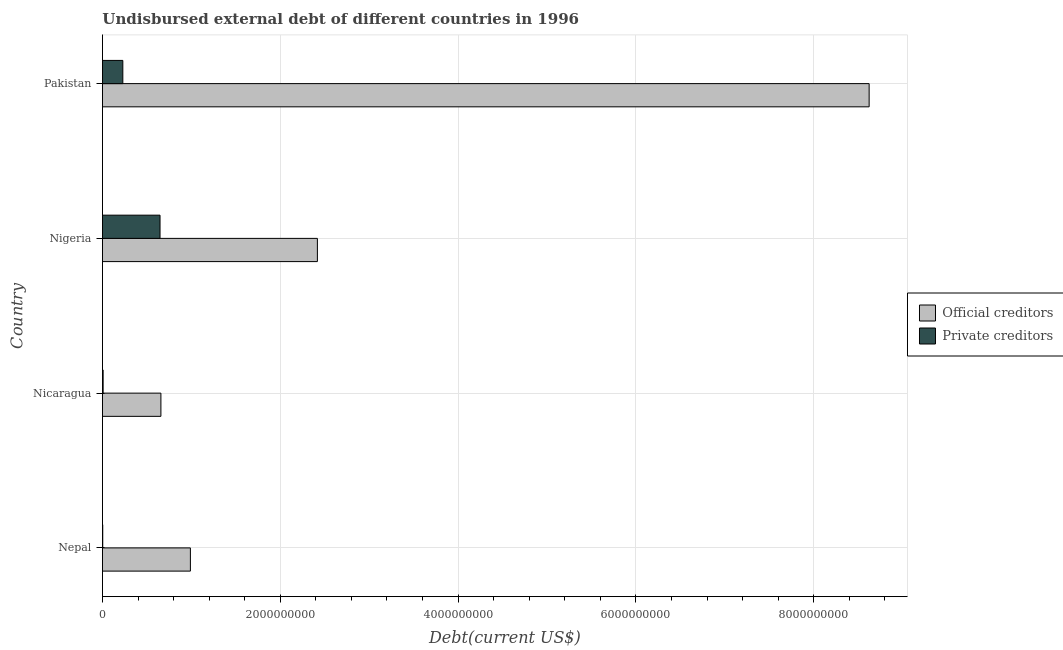Are the number of bars on each tick of the Y-axis equal?
Give a very brief answer. Yes. How many bars are there on the 4th tick from the bottom?
Your response must be concise. 2. What is the label of the 4th group of bars from the top?
Provide a short and direct response. Nepal. In how many cases, is the number of bars for a given country not equal to the number of legend labels?
Your answer should be very brief. 0. What is the undisbursed external debt of official creditors in Nepal?
Keep it short and to the point. 9.89e+08. Across all countries, what is the maximum undisbursed external debt of private creditors?
Offer a terse response. 6.48e+08. Across all countries, what is the minimum undisbursed external debt of official creditors?
Give a very brief answer. 6.57e+08. In which country was the undisbursed external debt of private creditors maximum?
Offer a very short reply. Nigeria. In which country was the undisbursed external debt of official creditors minimum?
Provide a succinct answer. Nicaragua. What is the total undisbursed external debt of private creditors in the graph?
Ensure brevity in your answer.  8.87e+08. What is the difference between the undisbursed external debt of official creditors in Nigeria and that in Pakistan?
Provide a short and direct response. -6.21e+09. What is the difference between the undisbursed external debt of private creditors in Pakistan and the undisbursed external debt of official creditors in Nepal?
Provide a short and direct response. -7.60e+08. What is the average undisbursed external debt of official creditors per country?
Give a very brief answer. 3.17e+09. What is the difference between the undisbursed external debt of private creditors and undisbursed external debt of official creditors in Nepal?
Give a very brief answer. -9.86e+08. What is the ratio of the undisbursed external debt of official creditors in Nicaragua to that in Pakistan?
Your answer should be very brief. 0.08. What is the difference between the highest and the second highest undisbursed external debt of private creditors?
Your answer should be very brief. 4.19e+08. What is the difference between the highest and the lowest undisbursed external debt of official creditors?
Offer a very short reply. 7.97e+09. In how many countries, is the undisbursed external debt of official creditors greater than the average undisbursed external debt of official creditors taken over all countries?
Provide a short and direct response. 1. Is the sum of the undisbursed external debt of official creditors in Nicaragua and Pakistan greater than the maximum undisbursed external debt of private creditors across all countries?
Offer a terse response. Yes. What does the 2nd bar from the top in Nigeria represents?
Keep it short and to the point. Official creditors. What does the 1st bar from the bottom in Nicaragua represents?
Ensure brevity in your answer.  Official creditors. How many bars are there?
Provide a short and direct response. 8. How many countries are there in the graph?
Keep it short and to the point. 4. Are the values on the major ticks of X-axis written in scientific E-notation?
Ensure brevity in your answer.  No. Does the graph contain any zero values?
Ensure brevity in your answer.  No. How many legend labels are there?
Give a very brief answer. 2. What is the title of the graph?
Your answer should be compact. Undisbursed external debt of different countries in 1996. Does "Diesel" appear as one of the legend labels in the graph?
Provide a short and direct response. No. What is the label or title of the X-axis?
Keep it short and to the point. Debt(current US$). What is the Debt(current US$) in Official creditors in Nepal?
Offer a very short reply. 9.89e+08. What is the Debt(current US$) in Private creditors in Nepal?
Offer a terse response. 3.13e+06. What is the Debt(current US$) of Official creditors in Nicaragua?
Provide a short and direct response. 6.57e+08. What is the Debt(current US$) in Private creditors in Nicaragua?
Offer a terse response. 7.37e+06. What is the Debt(current US$) of Official creditors in Nigeria?
Ensure brevity in your answer.  2.42e+09. What is the Debt(current US$) of Private creditors in Nigeria?
Give a very brief answer. 6.48e+08. What is the Debt(current US$) in Official creditors in Pakistan?
Offer a very short reply. 8.62e+09. What is the Debt(current US$) in Private creditors in Pakistan?
Provide a succinct answer. 2.29e+08. Across all countries, what is the maximum Debt(current US$) of Official creditors?
Keep it short and to the point. 8.62e+09. Across all countries, what is the maximum Debt(current US$) in Private creditors?
Offer a terse response. 6.48e+08. Across all countries, what is the minimum Debt(current US$) of Official creditors?
Your answer should be compact. 6.57e+08. Across all countries, what is the minimum Debt(current US$) in Private creditors?
Your response must be concise. 3.13e+06. What is the total Debt(current US$) in Official creditors in the graph?
Provide a short and direct response. 1.27e+1. What is the total Debt(current US$) of Private creditors in the graph?
Offer a terse response. 8.87e+08. What is the difference between the Debt(current US$) in Official creditors in Nepal and that in Nicaragua?
Give a very brief answer. 3.32e+08. What is the difference between the Debt(current US$) of Private creditors in Nepal and that in Nicaragua?
Make the answer very short. -4.24e+06. What is the difference between the Debt(current US$) in Official creditors in Nepal and that in Nigeria?
Make the answer very short. -1.43e+09. What is the difference between the Debt(current US$) of Private creditors in Nepal and that in Nigeria?
Your answer should be compact. -6.44e+08. What is the difference between the Debt(current US$) of Official creditors in Nepal and that in Pakistan?
Offer a terse response. -7.63e+09. What is the difference between the Debt(current US$) in Private creditors in Nepal and that in Pakistan?
Your answer should be very brief. -2.26e+08. What is the difference between the Debt(current US$) in Official creditors in Nicaragua and that in Nigeria?
Keep it short and to the point. -1.76e+09. What is the difference between the Debt(current US$) of Private creditors in Nicaragua and that in Nigeria?
Your answer should be compact. -6.40e+08. What is the difference between the Debt(current US$) in Official creditors in Nicaragua and that in Pakistan?
Offer a terse response. -7.97e+09. What is the difference between the Debt(current US$) of Private creditors in Nicaragua and that in Pakistan?
Provide a succinct answer. -2.22e+08. What is the difference between the Debt(current US$) of Official creditors in Nigeria and that in Pakistan?
Your answer should be very brief. -6.21e+09. What is the difference between the Debt(current US$) in Private creditors in Nigeria and that in Pakistan?
Keep it short and to the point. 4.19e+08. What is the difference between the Debt(current US$) in Official creditors in Nepal and the Debt(current US$) in Private creditors in Nicaragua?
Ensure brevity in your answer.  9.82e+08. What is the difference between the Debt(current US$) of Official creditors in Nepal and the Debt(current US$) of Private creditors in Nigeria?
Give a very brief answer. 3.41e+08. What is the difference between the Debt(current US$) in Official creditors in Nepal and the Debt(current US$) in Private creditors in Pakistan?
Ensure brevity in your answer.  7.60e+08. What is the difference between the Debt(current US$) of Official creditors in Nicaragua and the Debt(current US$) of Private creditors in Nigeria?
Your answer should be compact. 9.88e+06. What is the difference between the Debt(current US$) of Official creditors in Nicaragua and the Debt(current US$) of Private creditors in Pakistan?
Provide a short and direct response. 4.28e+08. What is the difference between the Debt(current US$) of Official creditors in Nigeria and the Debt(current US$) of Private creditors in Pakistan?
Keep it short and to the point. 2.19e+09. What is the average Debt(current US$) of Official creditors per country?
Make the answer very short. 3.17e+09. What is the average Debt(current US$) of Private creditors per country?
Provide a short and direct response. 2.22e+08. What is the difference between the Debt(current US$) of Official creditors and Debt(current US$) of Private creditors in Nepal?
Keep it short and to the point. 9.86e+08. What is the difference between the Debt(current US$) in Official creditors and Debt(current US$) in Private creditors in Nicaragua?
Provide a short and direct response. 6.50e+08. What is the difference between the Debt(current US$) of Official creditors and Debt(current US$) of Private creditors in Nigeria?
Your answer should be compact. 1.77e+09. What is the difference between the Debt(current US$) of Official creditors and Debt(current US$) of Private creditors in Pakistan?
Ensure brevity in your answer.  8.39e+09. What is the ratio of the Debt(current US$) of Official creditors in Nepal to that in Nicaragua?
Ensure brevity in your answer.  1.5. What is the ratio of the Debt(current US$) in Private creditors in Nepal to that in Nicaragua?
Ensure brevity in your answer.  0.42. What is the ratio of the Debt(current US$) of Official creditors in Nepal to that in Nigeria?
Provide a short and direct response. 0.41. What is the ratio of the Debt(current US$) of Private creditors in Nepal to that in Nigeria?
Your answer should be very brief. 0. What is the ratio of the Debt(current US$) in Official creditors in Nepal to that in Pakistan?
Your response must be concise. 0.11. What is the ratio of the Debt(current US$) of Private creditors in Nepal to that in Pakistan?
Offer a terse response. 0.01. What is the ratio of the Debt(current US$) in Official creditors in Nicaragua to that in Nigeria?
Make the answer very short. 0.27. What is the ratio of the Debt(current US$) in Private creditors in Nicaragua to that in Nigeria?
Keep it short and to the point. 0.01. What is the ratio of the Debt(current US$) in Official creditors in Nicaragua to that in Pakistan?
Your answer should be very brief. 0.08. What is the ratio of the Debt(current US$) in Private creditors in Nicaragua to that in Pakistan?
Offer a terse response. 0.03. What is the ratio of the Debt(current US$) of Official creditors in Nigeria to that in Pakistan?
Make the answer very short. 0.28. What is the ratio of the Debt(current US$) in Private creditors in Nigeria to that in Pakistan?
Give a very brief answer. 2.83. What is the difference between the highest and the second highest Debt(current US$) in Official creditors?
Provide a short and direct response. 6.21e+09. What is the difference between the highest and the second highest Debt(current US$) in Private creditors?
Provide a succinct answer. 4.19e+08. What is the difference between the highest and the lowest Debt(current US$) in Official creditors?
Your answer should be very brief. 7.97e+09. What is the difference between the highest and the lowest Debt(current US$) of Private creditors?
Offer a terse response. 6.44e+08. 